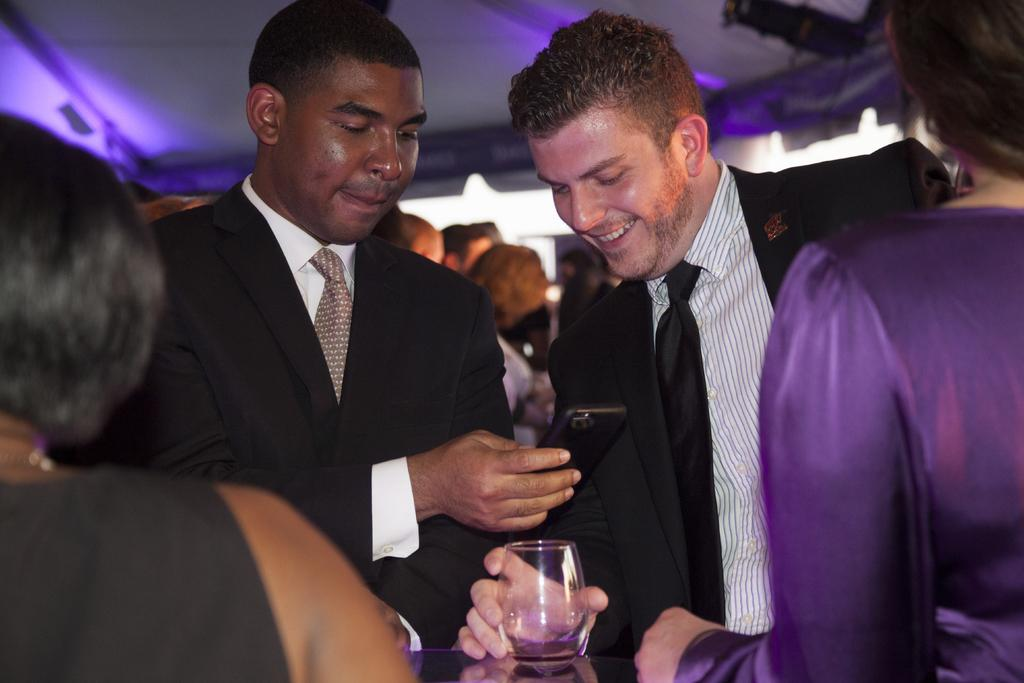How many people are in the group in the image? There is a group of people in the image, but the exact number is not specified. Can you describe the facial expression of one of the people in the group? One person in the group is smiling. What object is one person in the group holding? One person in the group is holding a mobile. What object is another person in the group holding? Another person in the group is holding a glass. What can be seen in the background of the image? There is a roof visible in the background of the image. What type of experience can be seen on the stage in the image? There is no stage present in the image; it features a group of people with a roof visible in the background. Can you describe the sofa that one person is sitting on in the image? There is no sofa present in the image; it features a group of people with a roof visible in the background. 